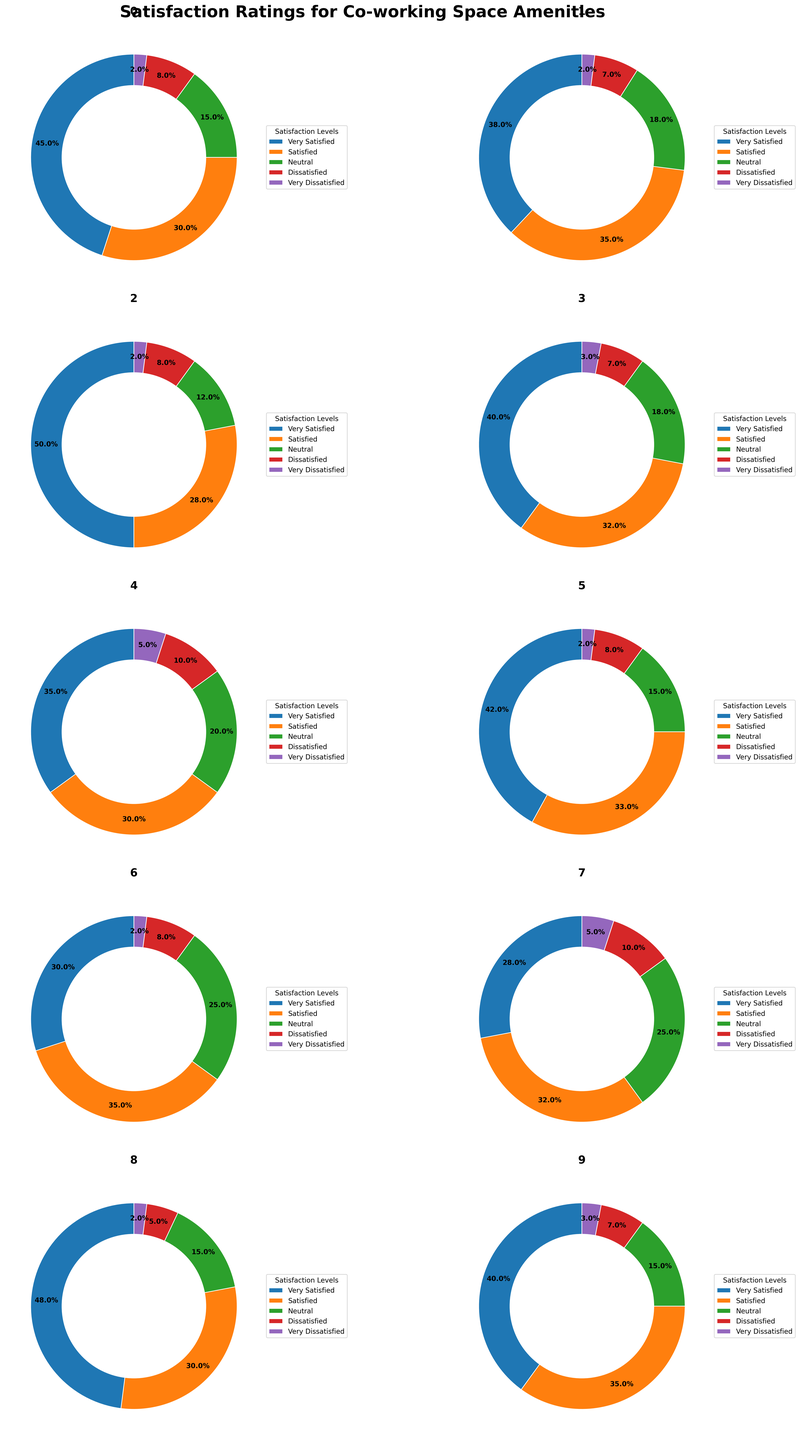How many amenities have "Very Satisfied" as the most popular rating? We need to count the number of amenities where the "Very Satisfied" segment occupies the largest proportion in the donut chart. By visually comparing each segment, we find that "Very Satisfied" is the largest in High-speed WiFi, Coffee Bar, Lounge Area, Event Space, and Cleaning Services.
Answer: 5 Which amenity has the highest percentage of "Dissatisfied" users? To find this, look for the largest "Dissatisfied" segment across all amenities. Printing Services has a significant "Dissatisfied" segment of 10%.
Answer: Printing Services What is the average percentage of "Neutral" ratings across all amenities? First, note the "Neutral" percentages for each amenity: 15%, 18%, 12%, 18%, 20%, 15%, 25%, 25%, 15%, 15%. Add these values (15+18+12+18+20+15+25+25+15+15 = 178) and divide by the number of amenities (10).
Answer: 17.8% Which two amenities have the closest "Satisfied" percentages? Compare the "Satisfied" segments to find the closest values. High-speed WiFi has 30% and Lounge Area has 33%, which are the closest.
Answer: High-speed WiFi and Lounge Area What is the total percentage of "Very Dissatisfied" users for all amenities combined? Sum the "Very Dissatisfied" percentages for each amenity: 2%, 2%, 2%, 3%, 5%, 2%, 2%, 5%, 2%, 3%. The total is (2+2+2+3+5+2+2+5+2+3) = 28%.
Answer: 28% Which amenity has the smallest "Very Satisfied" segment percentage? Look for the smallest "Very Satisfied" segment in the donut charts. Parking Facilities have the lowest at 28%.
Answer: Parking Facilities Are there any amenities where the percentage of "Satisfied" users is equal to the percentage of "Neutral" users? Check each amenity to see if the "Satisfied" and "Neutral" segments are equal. No amenities have these segments equal.
Answer: No Among amenities with at least 30% "Very Satisfied" users, which has the highest percentage of "Neutral" users? First identify amenities with at least 30% "Very Satisfied": High-speed WiFi, Coffee Bar, Meeting Rooms, Lounge Area, Event Space, Cleaning Services. Among these, Standing Desks have the highest "Neutral" at 25%.
Answer: Standing Desks 